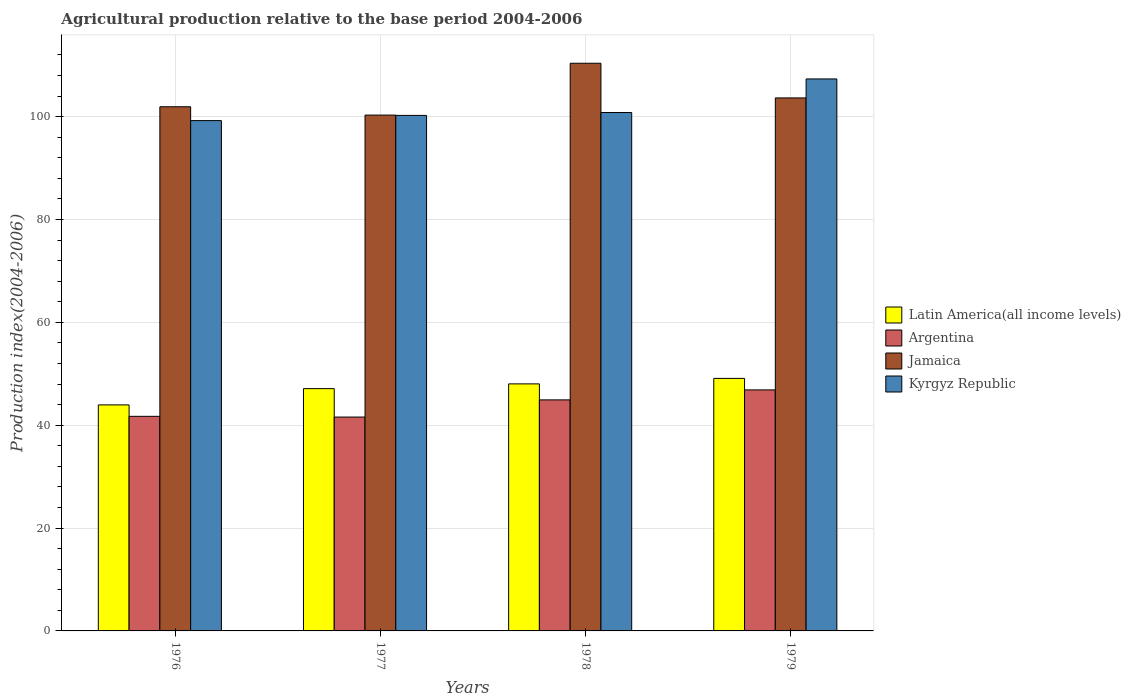Are the number of bars per tick equal to the number of legend labels?
Offer a terse response. Yes. Are the number of bars on each tick of the X-axis equal?
Make the answer very short. Yes. How many bars are there on the 3rd tick from the right?
Your answer should be compact. 4. In how many cases, is the number of bars for a given year not equal to the number of legend labels?
Make the answer very short. 0. What is the agricultural production index in Argentina in 1976?
Your response must be concise. 41.73. Across all years, what is the maximum agricultural production index in Kyrgyz Republic?
Your answer should be compact. 107.34. Across all years, what is the minimum agricultural production index in Kyrgyz Republic?
Your answer should be compact. 99.24. In which year was the agricultural production index in Latin America(all income levels) maximum?
Give a very brief answer. 1979. What is the total agricultural production index in Argentina in the graph?
Make the answer very short. 175.12. What is the difference between the agricultural production index in Jamaica in 1976 and that in 1978?
Your answer should be very brief. -8.46. What is the difference between the agricultural production index in Jamaica in 1978 and the agricultural production index in Argentina in 1979?
Provide a short and direct response. 63.52. What is the average agricultural production index in Kyrgyz Republic per year?
Offer a terse response. 101.91. In the year 1977, what is the difference between the agricultural production index in Kyrgyz Republic and agricultural production index in Argentina?
Ensure brevity in your answer.  58.66. In how many years, is the agricultural production index in Latin America(all income levels) greater than 100?
Your answer should be very brief. 0. What is the ratio of the agricultural production index in Latin America(all income levels) in 1976 to that in 1979?
Provide a short and direct response. 0.9. Is the agricultural production index in Kyrgyz Republic in 1978 less than that in 1979?
Offer a terse response. Yes. What is the difference between the highest and the second highest agricultural production index in Argentina?
Ensure brevity in your answer.  1.94. What is the difference between the highest and the lowest agricultural production index in Jamaica?
Ensure brevity in your answer.  10.08. What does the 1st bar from the left in 1978 represents?
Your answer should be compact. Latin America(all income levels). What does the 4th bar from the right in 1976 represents?
Offer a very short reply. Latin America(all income levels). Is it the case that in every year, the sum of the agricultural production index in Kyrgyz Republic and agricultural production index in Argentina is greater than the agricultural production index in Latin America(all income levels)?
Provide a succinct answer. Yes. How many bars are there?
Provide a succinct answer. 16. Does the graph contain any zero values?
Your answer should be very brief. No. What is the title of the graph?
Make the answer very short. Agricultural production relative to the base period 2004-2006. Does "Bangladesh" appear as one of the legend labels in the graph?
Provide a succinct answer. No. What is the label or title of the Y-axis?
Your response must be concise. Production index(2004-2006). What is the Production index(2004-2006) in Latin America(all income levels) in 1976?
Offer a terse response. 43.95. What is the Production index(2004-2006) in Argentina in 1976?
Your answer should be compact. 41.73. What is the Production index(2004-2006) in Jamaica in 1976?
Offer a terse response. 101.93. What is the Production index(2004-2006) in Kyrgyz Republic in 1976?
Your answer should be compact. 99.24. What is the Production index(2004-2006) of Latin America(all income levels) in 1977?
Ensure brevity in your answer.  47.12. What is the Production index(2004-2006) of Argentina in 1977?
Keep it short and to the point. 41.59. What is the Production index(2004-2006) in Jamaica in 1977?
Ensure brevity in your answer.  100.31. What is the Production index(2004-2006) in Kyrgyz Republic in 1977?
Give a very brief answer. 100.25. What is the Production index(2004-2006) of Latin America(all income levels) in 1978?
Give a very brief answer. 48.04. What is the Production index(2004-2006) in Argentina in 1978?
Your answer should be very brief. 44.93. What is the Production index(2004-2006) in Jamaica in 1978?
Keep it short and to the point. 110.39. What is the Production index(2004-2006) of Kyrgyz Republic in 1978?
Give a very brief answer. 100.81. What is the Production index(2004-2006) of Latin America(all income levels) in 1979?
Ensure brevity in your answer.  49.11. What is the Production index(2004-2006) in Argentina in 1979?
Your answer should be compact. 46.87. What is the Production index(2004-2006) of Jamaica in 1979?
Offer a terse response. 103.65. What is the Production index(2004-2006) in Kyrgyz Republic in 1979?
Keep it short and to the point. 107.34. Across all years, what is the maximum Production index(2004-2006) in Latin America(all income levels)?
Make the answer very short. 49.11. Across all years, what is the maximum Production index(2004-2006) in Argentina?
Your answer should be very brief. 46.87. Across all years, what is the maximum Production index(2004-2006) in Jamaica?
Offer a terse response. 110.39. Across all years, what is the maximum Production index(2004-2006) of Kyrgyz Republic?
Provide a short and direct response. 107.34. Across all years, what is the minimum Production index(2004-2006) in Latin America(all income levels)?
Make the answer very short. 43.95. Across all years, what is the minimum Production index(2004-2006) in Argentina?
Provide a succinct answer. 41.59. Across all years, what is the minimum Production index(2004-2006) of Jamaica?
Your answer should be very brief. 100.31. Across all years, what is the minimum Production index(2004-2006) in Kyrgyz Republic?
Make the answer very short. 99.24. What is the total Production index(2004-2006) in Latin America(all income levels) in the graph?
Provide a short and direct response. 188.21. What is the total Production index(2004-2006) of Argentina in the graph?
Your answer should be very brief. 175.12. What is the total Production index(2004-2006) in Jamaica in the graph?
Give a very brief answer. 416.28. What is the total Production index(2004-2006) in Kyrgyz Republic in the graph?
Keep it short and to the point. 407.64. What is the difference between the Production index(2004-2006) of Latin America(all income levels) in 1976 and that in 1977?
Your answer should be compact. -3.16. What is the difference between the Production index(2004-2006) of Argentina in 1976 and that in 1977?
Your answer should be compact. 0.14. What is the difference between the Production index(2004-2006) in Jamaica in 1976 and that in 1977?
Offer a very short reply. 1.62. What is the difference between the Production index(2004-2006) in Kyrgyz Republic in 1976 and that in 1977?
Offer a very short reply. -1.01. What is the difference between the Production index(2004-2006) of Latin America(all income levels) in 1976 and that in 1978?
Ensure brevity in your answer.  -4.09. What is the difference between the Production index(2004-2006) of Argentina in 1976 and that in 1978?
Your answer should be compact. -3.2. What is the difference between the Production index(2004-2006) of Jamaica in 1976 and that in 1978?
Ensure brevity in your answer.  -8.46. What is the difference between the Production index(2004-2006) in Kyrgyz Republic in 1976 and that in 1978?
Your answer should be compact. -1.57. What is the difference between the Production index(2004-2006) of Latin America(all income levels) in 1976 and that in 1979?
Keep it short and to the point. -5.15. What is the difference between the Production index(2004-2006) in Argentina in 1976 and that in 1979?
Make the answer very short. -5.14. What is the difference between the Production index(2004-2006) in Jamaica in 1976 and that in 1979?
Your answer should be very brief. -1.72. What is the difference between the Production index(2004-2006) in Latin America(all income levels) in 1977 and that in 1978?
Your answer should be very brief. -0.93. What is the difference between the Production index(2004-2006) of Argentina in 1977 and that in 1978?
Make the answer very short. -3.34. What is the difference between the Production index(2004-2006) of Jamaica in 1977 and that in 1978?
Give a very brief answer. -10.08. What is the difference between the Production index(2004-2006) of Kyrgyz Republic in 1977 and that in 1978?
Provide a succinct answer. -0.56. What is the difference between the Production index(2004-2006) of Latin America(all income levels) in 1977 and that in 1979?
Offer a very short reply. -1.99. What is the difference between the Production index(2004-2006) in Argentina in 1977 and that in 1979?
Offer a very short reply. -5.28. What is the difference between the Production index(2004-2006) in Jamaica in 1977 and that in 1979?
Ensure brevity in your answer.  -3.34. What is the difference between the Production index(2004-2006) of Kyrgyz Republic in 1977 and that in 1979?
Ensure brevity in your answer.  -7.09. What is the difference between the Production index(2004-2006) of Latin America(all income levels) in 1978 and that in 1979?
Your response must be concise. -1.07. What is the difference between the Production index(2004-2006) of Argentina in 1978 and that in 1979?
Your answer should be compact. -1.94. What is the difference between the Production index(2004-2006) of Jamaica in 1978 and that in 1979?
Your answer should be compact. 6.74. What is the difference between the Production index(2004-2006) of Kyrgyz Republic in 1978 and that in 1979?
Keep it short and to the point. -6.53. What is the difference between the Production index(2004-2006) of Latin America(all income levels) in 1976 and the Production index(2004-2006) of Argentina in 1977?
Provide a short and direct response. 2.36. What is the difference between the Production index(2004-2006) of Latin America(all income levels) in 1976 and the Production index(2004-2006) of Jamaica in 1977?
Provide a short and direct response. -56.36. What is the difference between the Production index(2004-2006) in Latin America(all income levels) in 1976 and the Production index(2004-2006) in Kyrgyz Republic in 1977?
Keep it short and to the point. -56.3. What is the difference between the Production index(2004-2006) of Argentina in 1976 and the Production index(2004-2006) of Jamaica in 1977?
Your answer should be very brief. -58.58. What is the difference between the Production index(2004-2006) of Argentina in 1976 and the Production index(2004-2006) of Kyrgyz Republic in 1977?
Make the answer very short. -58.52. What is the difference between the Production index(2004-2006) in Jamaica in 1976 and the Production index(2004-2006) in Kyrgyz Republic in 1977?
Your answer should be compact. 1.68. What is the difference between the Production index(2004-2006) in Latin America(all income levels) in 1976 and the Production index(2004-2006) in Argentina in 1978?
Give a very brief answer. -0.98. What is the difference between the Production index(2004-2006) of Latin America(all income levels) in 1976 and the Production index(2004-2006) of Jamaica in 1978?
Offer a terse response. -66.44. What is the difference between the Production index(2004-2006) in Latin America(all income levels) in 1976 and the Production index(2004-2006) in Kyrgyz Republic in 1978?
Make the answer very short. -56.86. What is the difference between the Production index(2004-2006) of Argentina in 1976 and the Production index(2004-2006) of Jamaica in 1978?
Provide a short and direct response. -68.66. What is the difference between the Production index(2004-2006) in Argentina in 1976 and the Production index(2004-2006) in Kyrgyz Republic in 1978?
Your answer should be compact. -59.08. What is the difference between the Production index(2004-2006) in Jamaica in 1976 and the Production index(2004-2006) in Kyrgyz Republic in 1978?
Your answer should be very brief. 1.12. What is the difference between the Production index(2004-2006) in Latin America(all income levels) in 1976 and the Production index(2004-2006) in Argentina in 1979?
Give a very brief answer. -2.92. What is the difference between the Production index(2004-2006) of Latin America(all income levels) in 1976 and the Production index(2004-2006) of Jamaica in 1979?
Provide a succinct answer. -59.7. What is the difference between the Production index(2004-2006) in Latin America(all income levels) in 1976 and the Production index(2004-2006) in Kyrgyz Republic in 1979?
Make the answer very short. -63.39. What is the difference between the Production index(2004-2006) of Argentina in 1976 and the Production index(2004-2006) of Jamaica in 1979?
Provide a succinct answer. -61.92. What is the difference between the Production index(2004-2006) in Argentina in 1976 and the Production index(2004-2006) in Kyrgyz Republic in 1979?
Provide a short and direct response. -65.61. What is the difference between the Production index(2004-2006) of Jamaica in 1976 and the Production index(2004-2006) of Kyrgyz Republic in 1979?
Your answer should be compact. -5.41. What is the difference between the Production index(2004-2006) of Latin America(all income levels) in 1977 and the Production index(2004-2006) of Argentina in 1978?
Provide a succinct answer. 2.19. What is the difference between the Production index(2004-2006) of Latin America(all income levels) in 1977 and the Production index(2004-2006) of Jamaica in 1978?
Your answer should be very brief. -63.27. What is the difference between the Production index(2004-2006) in Latin America(all income levels) in 1977 and the Production index(2004-2006) in Kyrgyz Republic in 1978?
Give a very brief answer. -53.69. What is the difference between the Production index(2004-2006) of Argentina in 1977 and the Production index(2004-2006) of Jamaica in 1978?
Ensure brevity in your answer.  -68.8. What is the difference between the Production index(2004-2006) of Argentina in 1977 and the Production index(2004-2006) of Kyrgyz Republic in 1978?
Give a very brief answer. -59.22. What is the difference between the Production index(2004-2006) of Latin America(all income levels) in 1977 and the Production index(2004-2006) of Argentina in 1979?
Provide a short and direct response. 0.25. What is the difference between the Production index(2004-2006) of Latin America(all income levels) in 1977 and the Production index(2004-2006) of Jamaica in 1979?
Keep it short and to the point. -56.53. What is the difference between the Production index(2004-2006) in Latin America(all income levels) in 1977 and the Production index(2004-2006) in Kyrgyz Republic in 1979?
Offer a very short reply. -60.22. What is the difference between the Production index(2004-2006) of Argentina in 1977 and the Production index(2004-2006) of Jamaica in 1979?
Keep it short and to the point. -62.06. What is the difference between the Production index(2004-2006) in Argentina in 1977 and the Production index(2004-2006) in Kyrgyz Republic in 1979?
Provide a succinct answer. -65.75. What is the difference between the Production index(2004-2006) in Jamaica in 1977 and the Production index(2004-2006) in Kyrgyz Republic in 1979?
Offer a terse response. -7.03. What is the difference between the Production index(2004-2006) in Latin America(all income levels) in 1978 and the Production index(2004-2006) in Argentina in 1979?
Offer a very short reply. 1.17. What is the difference between the Production index(2004-2006) of Latin America(all income levels) in 1978 and the Production index(2004-2006) of Jamaica in 1979?
Give a very brief answer. -55.61. What is the difference between the Production index(2004-2006) in Latin America(all income levels) in 1978 and the Production index(2004-2006) in Kyrgyz Republic in 1979?
Your response must be concise. -59.3. What is the difference between the Production index(2004-2006) of Argentina in 1978 and the Production index(2004-2006) of Jamaica in 1979?
Your answer should be very brief. -58.72. What is the difference between the Production index(2004-2006) of Argentina in 1978 and the Production index(2004-2006) of Kyrgyz Republic in 1979?
Your answer should be compact. -62.41. What is the difference between the Production index(2004-2006) of Jamaica in 1978 and the Production index(2004-2006) of Kyrgyz Republic in 1979?
Make the answer very short. 3.05. What is the average Production index(2004-2006) in Latin America(all income levels) per year?
Offer a terse response. 47.05. What is the average Production index(2004-2006) of Argentina per year?
Your response must be concise. 43.78. What is the average Production index(2004-2006) of Jamaica per year?
Ensure brevity in your answer.  104.07. What is the average Production index(2004-2006) in Kyrgyz Republic per year?
Provide a short and direct response. 101.91. In the year 1976, what is the difference between the Production index(2004-2006) of Latin America(all income levels) and Production index(2004-2006) of Argentina?
Your answer should be very brief. 2.22. In the year 1976, what is the difference between the Production index(2004-2006) in Latin America(all income levels) and Production index(2004-2006) in Jamaica?
Keep it short and to the point. -57.98. In the year 1976, what is the difference between the Production index(2004-2006) of Latin America(all income levels) and Production index(2004-2006) of Kyrgyz Republic?
Offer a very short reply. -55.29. In the year 1976, what is the difference between the Production index(2004-2006) in Argentina and Production index(2004-2006) in Jamaica?
Ensure brevity in your answer.  -60.2. In the year 1976, what is the difference between the Production index(2004-2006) in Argentina and Production index(2004-2006) in Kyrgyz Republic?
Your answer should be very brief. -57.51. In the year 1976, what is the difference between the Production index(2004-2006) in Jamaica and Production index(2004-2006) in Kyrgyz Republic?
Ensure brevity in your answer.  2.69. In the year 1977, what is the difference between the Production index(2004-2006) in Latin America(all income levels) and Production index(2004-2006) in Argentina?
Offer a terse response. 5.53. In the year 1977, what is the difference between the Production index(2004-2006) in Latin America(all income levels) and Production index(2004-2006) in Jamaica?
Your answer should be compact. -53.19. In the year 1977, what is the difference between the Production index(2004-2006) of Latin America(all income levels) and Production index(2004-2006) of Kyrgyz Republic?
Provide a short and direct response. -53.13. In the year 1977, what is the difference between the Production index(2004-2006) in Argentina and Production index(2004-2006) in Jamaica?
Make the answer very short. -58.72. In the year 1977, what is the difference between the Production index(2004-2006) in Argentina and Production index(2004-2006) in Kyrgyz Republic?
Your response must be concise. -58.66. In the year 1977, what is the difference between the Production index(2004-2006) of Jamaica and Production index(2004-2006) of Kyrgyz Republic?
Provide a succinct answer. 0.06. In the year 1978, what is the difference between the Production index(2004-2006) in Latin America(all income levels) and Production index(2004-2006) in Argentina?
Make the answer very short. 3.11. In the year 1978, what is the difference between the Production index(2004-2006) in Latin America(all income levels) and Production index(2004-2006) in Jamaica?
Your answer should be compact. -62.35. In the year 1978, what is the difference between the Production index(2004-2006) of Latin America(all income levels) and Production index(2004-2006) of Kyrgyz Republic?
Make the answer very short. -52.77. In the year 1978, what is the difference between the Production index(2004-2006) in Argentina and Production index(2004-2006) in Jamaica?
Ensure brevity in your answer.  -65.46. In the year 1978, what is the difference between the Production index(2004-2006) of Argentina and Production index(2004-2006) of Kyrgyz Republic?
Provide a succinct answer. -55.88. In the year 1978, what is the difference between the Production index(2004-2006) in Jamaica and Production index(2004-2006) in Kyrgyz Republic?
Ensure brevity in your answer.  9.58. In the year 1979, what is the difference between the Production index(2004-2006) of Latin America(all income levels) and Production index(2004-2006) of Argentina?
Offer a very short reply. 2.24. In the year 1979, what is the difference between the Production index(2004-2006) of Latin America(all income levels) and Production index(2004-2006) of Jamaica?
Offer a terse response. -54.54. In the year 1979, what is the difference between the Production index(2004-2006) of Latin America(all income levels) and Production index(2004-2006) of Kyrgyz Republic?
Provide a short and direct response. -58.23. In the year 1979, what is the difference between the Production index(2004-2006) of Argentina and Production index(2004-2006) of Jamaica?
Provide a succinct answer. -56.78. In the year 1979, what is the difference between the Production index(2004-2006) in Argentina and Production index(2004-2006) in Kyrgyz Republic?
Your answer should be very brief. -60.47. In the year 1979, what is the difference between the Production index(2004-2006) of Jamaica and Production index(2004-2006) of Kyrgyz Republic?
Offer a very short reply. -3.69. What is the ratio of the Production index(2004-2006) of Latin America(all income levels) in 1976 to that in 1977?
Keep it short and to the point. 0.93. What is the ratio of the Production index(2004-2006) in Jamaica in 1976 to that in 1977?
Your response must be concise. 1.02. What is the ratio of the Production index(2004-2006) of Kyrgyz Republic in 1976 to that in 1977?
Provide a succinct answer. 0.99. What is the ratio of the Production index(2004-2006) in Latin America(all income levels) in 1976 to that in 1978?
Your answer should be compact. 0.91. What is the ratio of the Production index(2004-2006) of Argentina in 1976 to that in 1978?
Your answer should be very brief. 0.93. What is the ratio of the Production index(2004-2006) of Jamaica in 1976 to that in 1978?
Give a very brief answer. 0.92. What is the ratio of the Production index(2004-2006) in Kyrgyz Republic in 1976 to that in 1978?
Your answer should be compact. 0.98. What is the ratio of the Production index(2004-2006) in Latin America(all income levels) in 1976 to that in 1979?
Your answer should be very brief. 0.9. What is the ratio of the Production index(2004-2006) in Argentina in 1976 to that in 1979?
Offer a terse response. 0.89. What is the ratio of the Production index(2004-2006) in Jamaica in 1976 to that in 1979?
Ensure brevity in your answer.  0.98. What is the ratio of the Production index(2004-2006) of Kyrgyz Republic in 1976 to that in 1979?
Your response must be concise. 0.92. What is the ratio of the Production index(2004-2006) in Latin America(all income levels) in 1977 to that in 1978?
Your response must be concise. 0.98. What is the ratio of the Production index(2004-2006) in Argentina in 1977 to that in 1978?
Your answer should be compact. 0.93. What is the ratio of the Production index(2004-2006) in Jamaica in 1977 to that in 1978?
Your answer should be very brief. 0.91. What is the ratio of the Production index(2004-2006) of Latin America(all income levels) in 1977 to that in 1979?
Provide a short and direct response. 0.96. What is the ratio of the Production index(2004-2006) in Argentina in 1977 to that in 1979?
Ensure brevity in your answer.  0.89. What is the ratio of the Production index(2004-2006) of Jamaica in 1977 to that in 1979?
Your answer should be compact. 0.97. What is the ratio of the Production index(2004-2006) of Kyrgyz Republic in 1977 to that in 1979?
Give a very brief answer. 0.93. What is the ratio of the Production index(2004-2006) in Latin America(all income levels) in 1978 to that in 1979?
Make the answer very short. 0.98. What is the ratio of the Production index(2004-2006) of Argentina in 1978 to that in 1979?
Offer a very short reply. 0.96. What is the ratio of the Production index(2004-2006) in Jamaica in 1978 to that in 1979?
Your response must be concise. 1.06. What is the ratio of the Production index(2004-2006) in Kyrgyz Republic in 1978 to that in 1979?
Provide a short and direct response. 0.94. What is the difference between the highest and the second highest Production index(2004-2006) of Latin America(all income levels)?
Give a very brief answer. 1.07. What is the difference between the highest and the second highest Production index(2004-2006) in Argentina?
Keep it short and to the point. 1.94. What is the difference between the highest and the second highest Production index(2004-2006) of Jamaica?
Offer a terse response. 6.74. What is the difference between the highest and the second highest Production index(2004-2006) of Kyrgyz Republic?
Make the answer very short. 6.53. What is the difference between the highest and the lowest Production index(2004-2006) in Latin America(all income levels)?
Give a very brief answer. 5.15. What is the difference between the highest and the lowest Production index(2004-2006) of Argentina?
Offer a terse response. 5.28. What is the difference between the highest and the lowest Production index(2004-2006) of Jamaica?
Give a very brief answer. 10.08. What is the difference between the highest and the lowest Production index(2004-2006) of Kyrgyz Republic?
Provide a short and direct response. 8.1. 